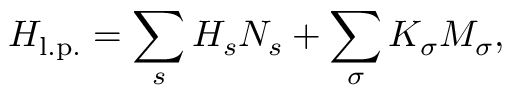Convert formula to latex. <formula><loc_0><loc_0><loc_500><loc_500>H _ { l . p . } = \sum _ { s } H _ { s } N _ { s } + \sum _ { \sigma } K _ { \sigma } M _ { \sigma } ,</formula> 